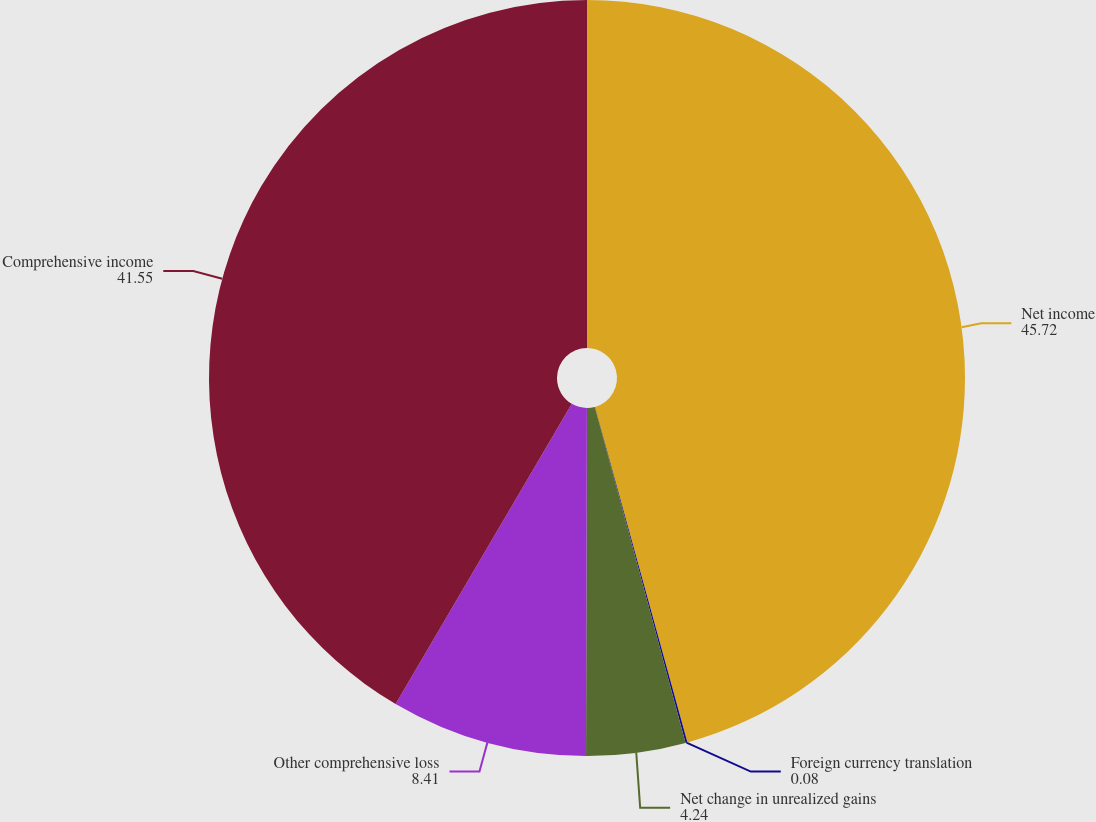<chart> <loc_0><loc_0><loc_500><loc_500><pie_chart><fcel>Net income<fcel>Foreign currency translation<fcel>Net change in unrealized gains<fcel>Other comprehensive loss<fcel>Comprehensive income<nl><fcel>45.72%<fcel>0.08%<fcel>4.24%<fcel>8.41%<fcel>41.55%<nl></chart> 